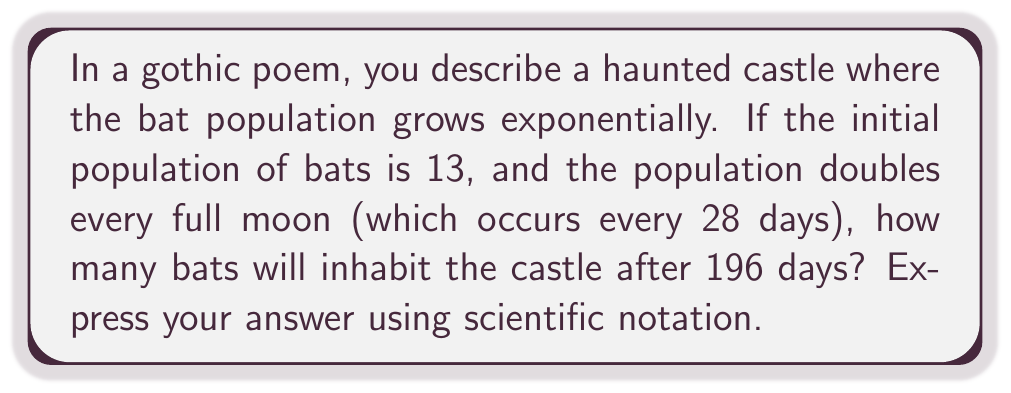Give your solution to this math problem. Let's approach this problem step-by-step:

1) First, we need to determine how many times the population doubles in 196 days.
   - Each doubling occurs every 28 days
   - Number of doublings = $\frac{196 \text{ days}}{28 \text{ days per doubling}} = 7$

2) We can express this growth using the exponential formula:
   $$ P = P_0 \cdot 2^n $$
   Where:
   $P$ is the final population
   $P_0$ is the initial population (13 bats)
   $2$ is the growth factor (population doubles)
   $n$ is the number of doublings (7)

3) Let's substitute these values:
   $$ P = 13 \cdot 2^7 $$

4) Now we calculate:
   $$ P = 13 \cdot 128 = 1,664 $$

5) To express this in scientific notation, we move the decimal point to the left until we have a number between 1 and 10, and then count how many places we moved:
   $$ 1,664 = 1.664 \times 10^3 $$

Thus, after 196 days, the bat population in the haunted castle will be $1.664 \times 10^3$.
Answer: $1.664 \times 10^3$ bats 